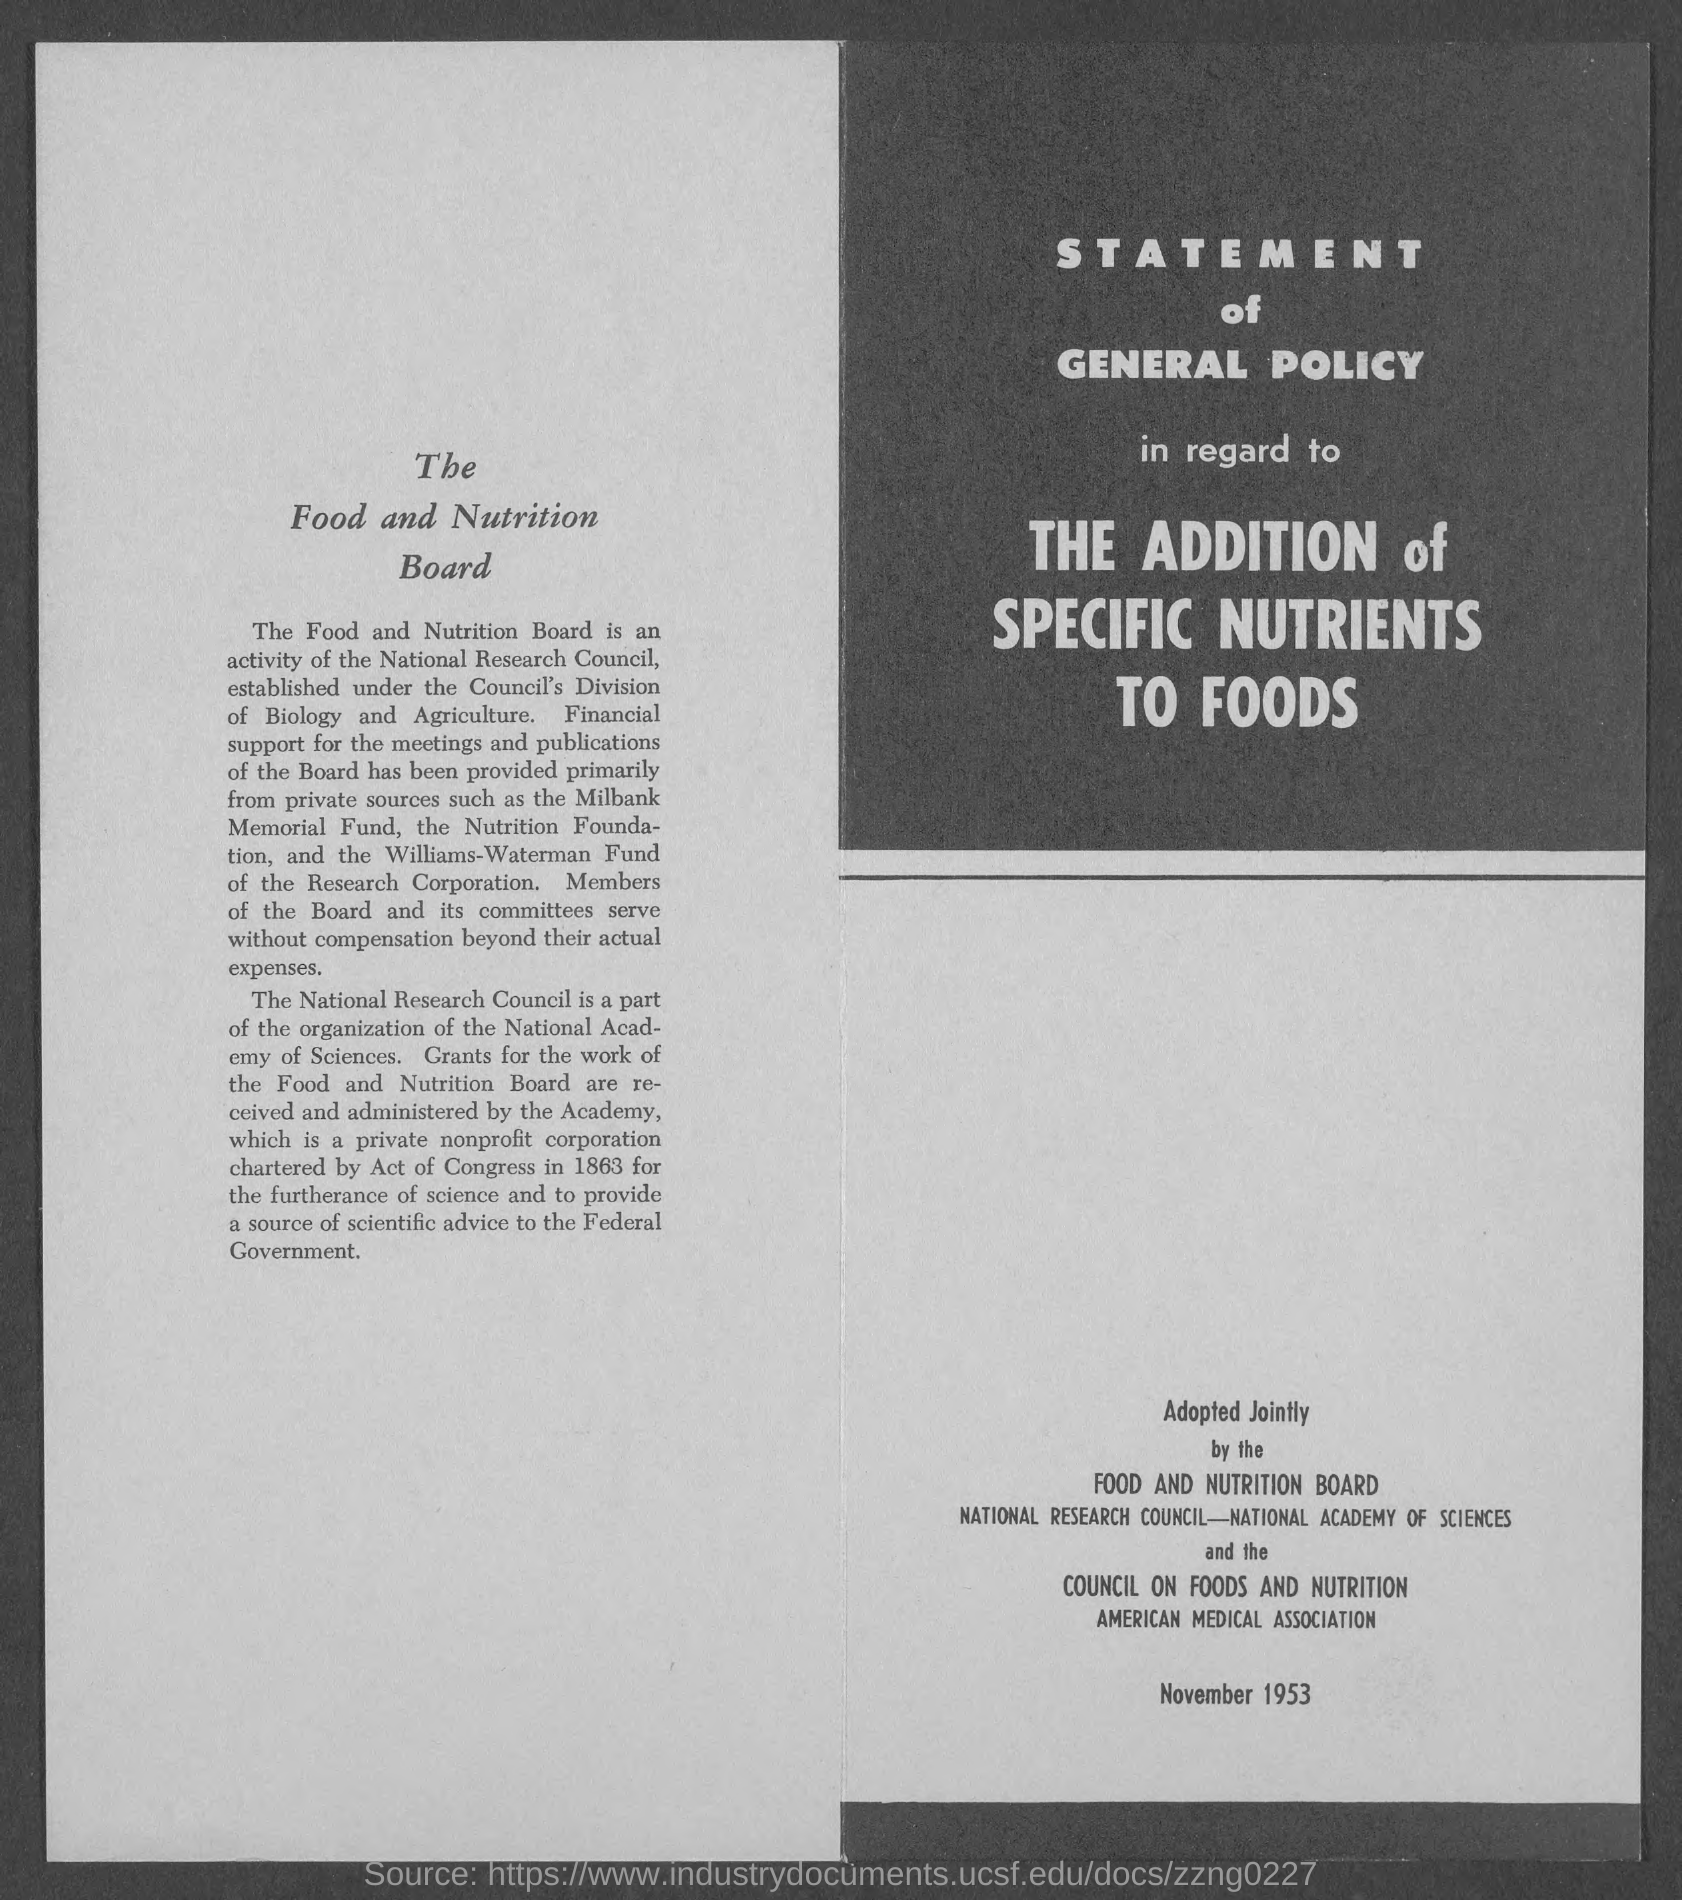What kind of a statement is this?
Make the answer very short. Statement of General Policy. What is this statement of general policy about?
Make the answer very short. The addition of Specific Nutrients to Foods. The private nonprofit corporation chartered by which Act ?
Offer a terse response. Act of Congress in 1863. 